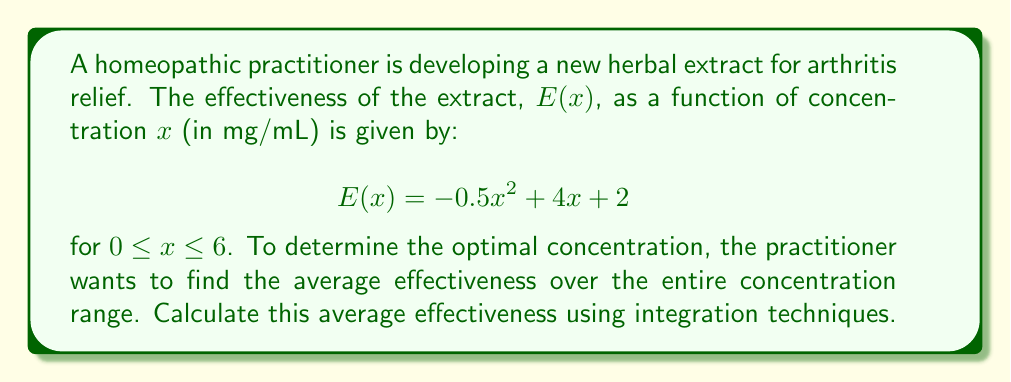Can you answer this question? To solve this problem, we need to follow these steps:

1) The average value of a function $f(x)$ over an interval $[a,b]$ is given by:

   $$\text{Average} = \frac{1}{b-a} \int_a^b f(x) dx$$

2) In our case, $f(x) = E(x) = -0.5x^2 + 4x + 2$, $a=0$, and $b=6$. Let's substitute these into the formula:

   $$\text{Average} = \frac{1}{6-0} \int_0^6 (-0.5x^2 + 4x + 2) dx$$

3) Simplify:

   $$\text{Average} = \frac{1}{6} \int_0^6 (-0.5x^2 + 4x + 2) dx$$

4) Now, let's integrate:

   $$\begin{align*}
   \text{Average} &= \frac{1}{6} \left[-\frac{1}{6}x^3 + 2x^2 + 2x\right]_0^6 \\
   &= \frac{1}{6} \left(\left[-\frac{1}{6}(6^3) + 2(6^2) + 2(6)\right] - \left[-\frac{1}{6}(0^3) + 2(0^2) + 2(0)\right]\right)
   \end{align*}$$

5) Evaluate:

   $$\begin{align*}
   \text{Average} &= \frac{1}{6} \left(-36 + 72 + 12 - 0\right) \\
   &= \frac{1}{6} (48) \\
   &= 8
   \end{align*}$$

Therefore, the average effectiveness of the herbal extract over the concentration range is 8.
Answer: The average effectiveness of the herbal extract over the concentration range of 0 to 6 mg/mL is 8. 